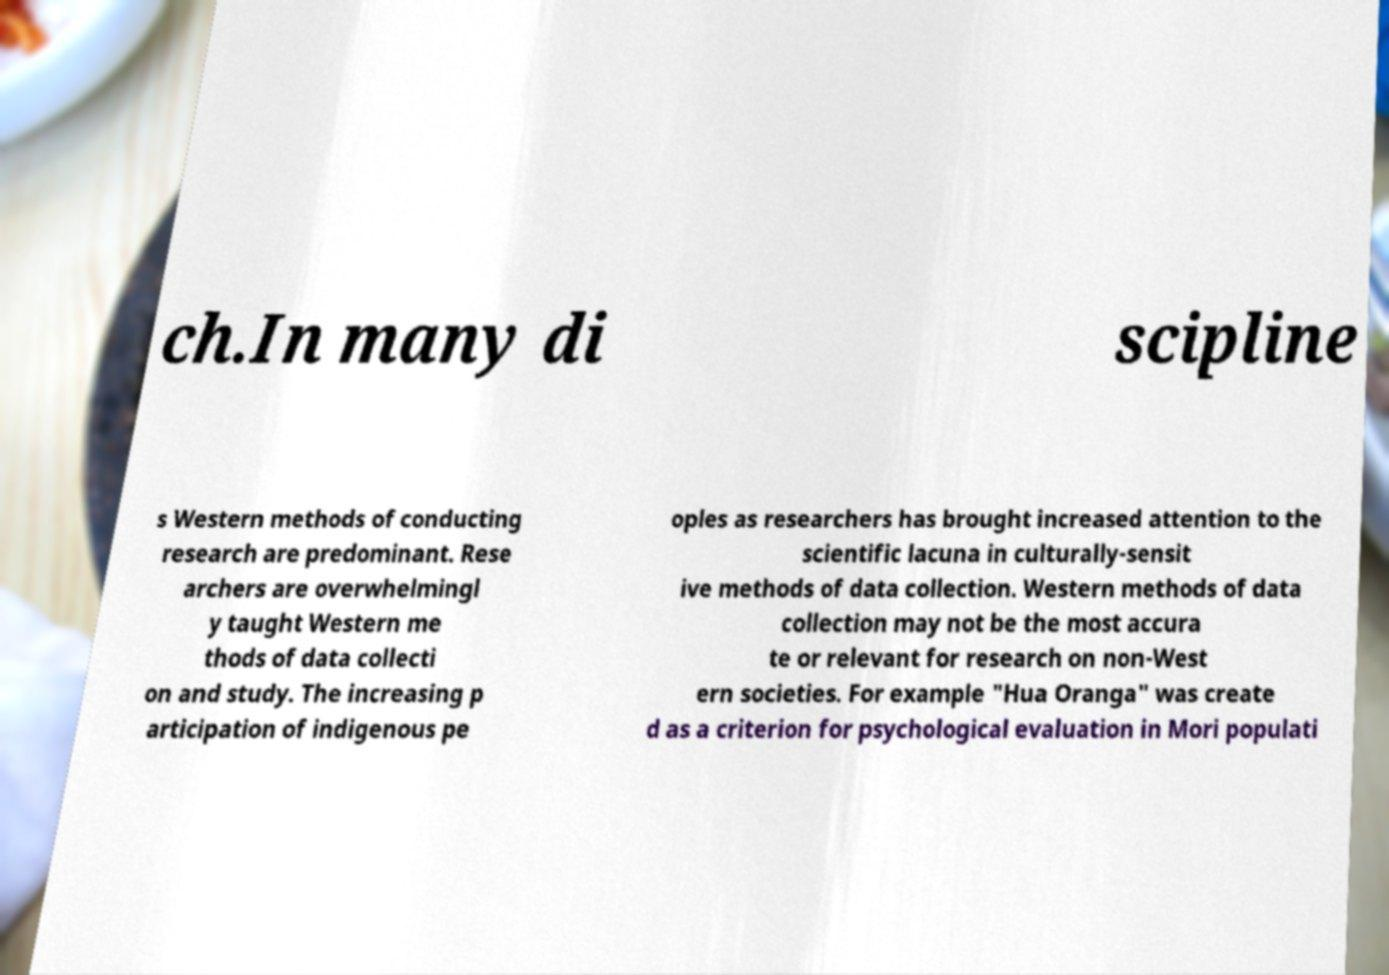There's text embedded in this image that I need extracted. Can you transcribe it verbatim? ch.In many di scipline s Western methods of conducting research are predominant. Rese archers are overwhelmingl y taught Western me thods of data collecti on and study. The increasing p articipation of indigenous pe oples as researchers has brought increased attention to the scientific lacuna in culturally-sensit ive methods of data collection. Western methods of data collection may not be the most accura te or relevant for research on non-West ern societies. For example "Hua Oranga" was create d as a criterion for psychological evaluation in Mori populati 